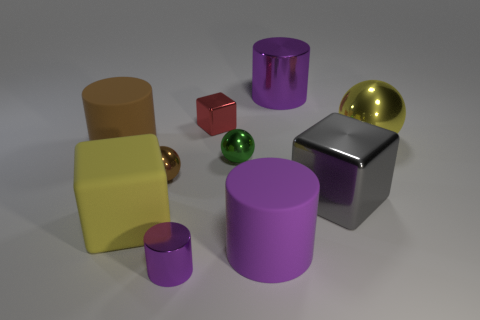Subtract all blue spheres. How many purple cylinders are left? 3 Subtract all green cylinders. Subtract all cyan balls. How many cylinders are left? 4 Subtract all cylinders. How many objects are left? 6 Subtract all cyan objects. Subtract all green things. How many objects are left? 9 Add 2 rubber blocks. How many rubber blocks are left? 3 Add 4 purple things. How many purple things exist? 7 Subtract 1 gray blocks. How many objects are left? 9 